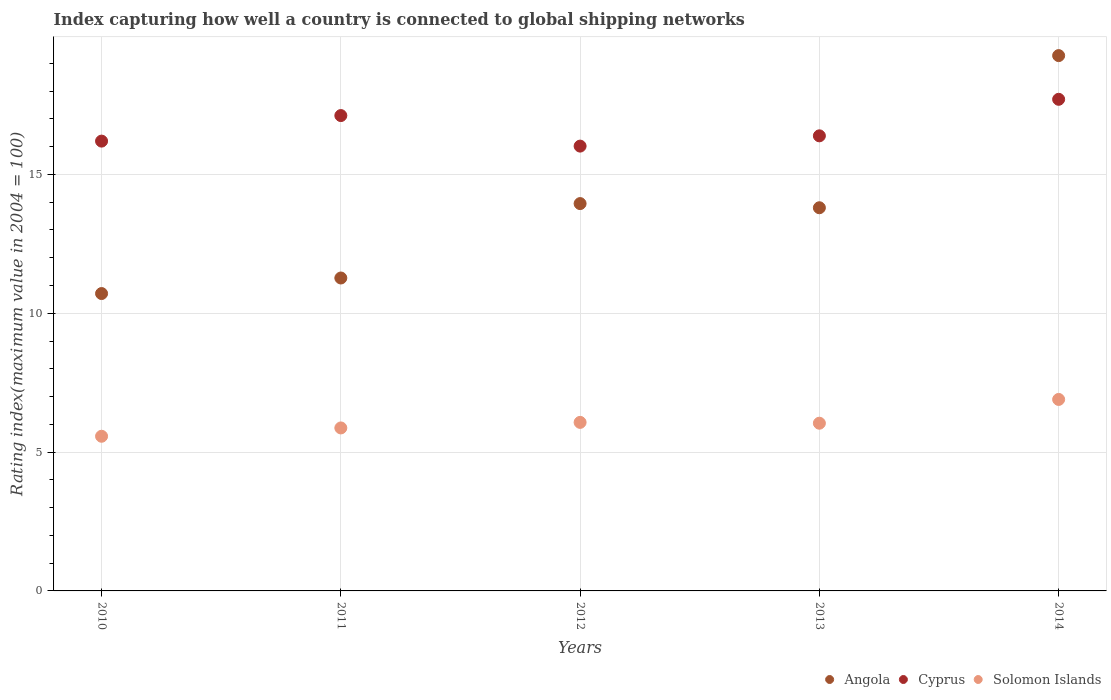How many different coloured dotlines are there?
Your answer should be very brief. 3. What is the rating index in Cyprus in 2010?
Offer a very short reply. 16.2. Across all years, what is the maximum rating index in Angola?
Offer a very short reply. 19.28. Across all years, what is the minimum rating index in Solomon Islands?
Your answer should be very brief. 5.57. What is the total rating index in Cyprus in the graph?
Ensure brevity in your answer.  83.44. What is the difference between the rating index in Cyprus in 2013 and that in 2014?
Keep it short and to the point. -1.32. What is the difference between the rating index in Cyprus in 2011 and the rating index in Angola in 2010?
Your answer should be very brief. 6.41. What is the average rating index in Angola per year?
Offer a terse response. 13.8. In the year 2010, what is the difference between the rating index in Angola and rating index in Cyprus?
Ensure brevity in your answer.  -5.49. What is the ratio of the rating index in Cyprus in 2011 to that in 2014?
Make the answer very short. 0.97. Is the difference between the rating index in Angola in 2011 and 2012 greater than the difference between the rating index in Cyprus in 2011 and 2012?
Ensure brevity in your answer.  No. What is the difference between the highest and the second highest rating index in Cyprus?
Your answer should be very brief. 0.59. What is the difference between the highest and the lowest rating index in Solomon Islands?
Keep it short and to the point. 1.33. Is it the case that in every year, the sum of the rating index in Solomon Islands and rating index in Angola  is greater than the rating index in Cyprus?
Your answer should be compact. Yes. Does the rating index in Angola monotonically increase over the years?
Give a very brief answer. No. Is the rating index in Cyprus strictly greater than the rating index in Solomon Islands over the years?
Ensure brevity in your answer.  Yes. Is the rating index in Solomon Islands strictly less than the rating index in Angola over the years?
Offer a very short reply. Yes. Does the graph contain grids?
Make the answer very short. Yes. Where does the legend appear in the graph?
Your response must be concise. Bottom right. How many legend labels are there?
Provide a short and direct response. 3. How are the legend labels stacked?
Keep it short and to the point. Horizontal. What is the title of the graph?
Ensure brevity in your answer.  Index capturing how well a country is connected to global shipping networks. What is the label or title of the X-axis?
Provide a short and direct response. Years. What is the label or title of the Y-axis?
Your answer should be compact. Rating index(maximum value in 2004 = 100). What is the Rating index(maximum value in 2004 = 100) in Angola in 2010?
Provide a succinct answer. 10.71. What is the Rating index(maximum value in 2004 = 100) in Cyprus in 2010?
Offer a terse response. 16.2. What is the Rating index(maximum value in 2004 = 100) of Solomon Islands in 2010?
Provide a succinct answer. 5.57. What is the Rating index(maximum value in 2004 = 100) in Angola in 2011?
Ensure brevity in your answer.  11.27. What is the Rating index(maximum value in 2004 = 100) of Cyprus in 2011?
Provide a short and direct response. 17.12. What is the Rating index(maximum value in 2004 = 100) of Solomon Islands in 2011?
Your answer should be very brief. 5.87. What is the Rating index(maximum value in 2004 = 100) of Angola in 2012?
Keep it short and to the point. 13.95. What is the Rating index(maximum value in 2004 = 100) of Cyprus in 2012?
Your answer should be very brief. 16.02. What is the Rating index(maximum value in 2004 = 100) in Solomon Islands in 2012?
Keep it short and to the point. 6.07. What is the Rating index(maximum value in 2004 = 100) in Cyprus in 2013?
Your response must be concise. 16.39. What is the Rating index(maximum value in 2004 = 100) of Solomon Islands in 2013?
Make the answer very short. 6.04. What is the Rating index(maximum value in 2004 = 100) of Angola in 2014?
Keep it short and to the point. 19.28. What is the Rating index(maximum value in 2004 = 100) in Cyprus in 2014?
Keep it short and to the point. 17.71. What is the Rating index(maximum value in 2004 = 100) in Solomon Islands in 2014?
Offer a very short reply. 6.9. Across all years, what is the maximum Rating index(maximum value in 2004 = 100) of Angola?
Ensure brevity in your answer.  19.28. Across all years, what is the maximum Rating index(maximum value in 2004 = 100) in Cyprus?
Provide a succinct answer. 17.71. Across all years, what is the maximum Rating index(maximum value in 2004 = 100) in Solomon Islands?
Provide a succinct answer. 6.9. Across all years, what is the minimum Rating index(maximum value in 2004 = 100) in Angola?
Offer a terse response. 10.71. Across all years, what is the minimum Rating index(maximum value in 2004 = 100) in Cyprus?
Ensure brevity in your answer.  16.02. Across all years, what is the minimum Rating index(maximum value in 2004 = 100) of Solomon Islands?
Your answer should be very brief. 5.57. What is the total Rating index(maximum value in 2004 = 100) in Angola in the graph?
Offer a very short reply. 69.01. What is the total Rating index(maximum value in 2004 = 100) in Cyprus in the graph?
Make the answer very short. 83.44. What is the total Rating index(maximum value in 2004 = 100) of Solomon Islands in the graph?
Your answer should be compact. 30.45. What is the difference between the Rating index(maximum value in 2004 = 100) in Angola in 2010 and that in 2011?
Your answer should be very brief. -0.56. What is the difference between the Rating index(maximum value in 2004 = 100) of Cyprus in 2010 and that in 2011?
Offer a terse response. -0.92. What is the difference between the Rating index(maximum value in 2004 = 100) in Solomon Islands in 2010 and that in 2011?
Offer a very short reply. -0.3. What is the difference between the Rating index(maximum value in 2004 = 100) in Angola in 2010 and that in 2012?
Offer a very short reply. -3.24. What is the difference between the Rating index(maximum value in 2004 = 100) of Cyprus in 2010 and that in 2012?
Offer a very short reply. 0.18. What is the difference between the Rating index(maximum value in 2004 = 100) in Angola in 2010 and that in 2013?
Ensure brevity in your answer.  -3.09. What is the difference between the Rating index(maximum value in 2004 = 100) in Cyprus in 2010 and that in 2013?
Your answer should be very brief. -0.19. What is the difference between the Rating index(maximum value in 2004 = 100) in Solomon Islands in 2010 and that in 2013?
Provide a short and direct response. -0.47. What is the difference between the Rating index(maximum value in 2004 = 100) of Angola in 2010 and that in 2014?
Your answer should be very brief. -8.57. What is the difference between the Rating index(maximum value in 2004 = 100) in Cyprus in 2010 and that in 2014?
Offer a very short reply. -1.51. What is the difference between the Rating index(maximum value in 2004 = 100) of Solomon Islands in 2010 and that in 2014?
Provide a succinct answer. -1.33. What is the difference between the Rating index(maximum value in 2004 = 100) in Angola in 2011 and that in 2012?
Ensure brevity in your answer.  -2.68. What is the difference between the Rating index(maximum value in 2004 = 100) of Cyprus in 2011 and that in 2012?
Provide a short and direct response. 1.1. What is the difference between the Rating index(maximum value in 2004 = 100) in Solomon Islands in 2011 and that in 2012?
Offer a very short reply. -0.2. What is the difference between the Rating index(maximum value in 2004 = 100) in Angola in 2011 and that in 2013?
Offer a very short reply. -2.53. What is the difference between the Rating index(maximum value in 2004 = 100) of Cyprus in 2011 and that in 2013?
Your response must be concise. 0.73. What is the difference between the Rating index(maximum value in 2004 = 100) in Solomon Islands in 2011 and that in 2013?
Your response must be concise. -0.17. What is the difference between the Rating index(maximum value in 2004 = 100) of Angola in 2011 and that in 2014?
Your answer should be very brief. -8.01. What is the difference between the Rating index(maximum value in 2004 = 100) in Cyprus in 2011 and that in 2014?
Keep it short and to the point. -0.59. What is the difference between the Rating index(maximum value in 2004 = 100) in Solomon Islands in 2011 and that in 2014?
Provide a short and direct response. -1.03. What is the difference between the Rating index(maximum value in 2004 = 100) of Angola in 2012 and that in 2013?
Offer a terse response. 0.15. What is the difference between the Rating index(maximum value in 2004 = 100) of Cyprus in 2012 and that in 2013?
Offer a terse response. -0.37. What is the difference between the Rating index(maximum value in 2004 = 100) of Angola in 2012 and that in 2014?
Offer a very short reply. -5.33. What is the difference between the Rating index(maximum value in 2004 = 100) in Cyprus in 2012 and that in 2014?
Make the answer very short. -1.69. What is the difference between the Rating index(maximum value in 2004 = 100) of Solomon Islands in 2012 and that in 2014?
Keep it short and to the point. -0.83. What is the difference between the Rating index(maximum value in 2004 = 100) in Angola in 2013 and that in 2014?
Offer a very short reply. -5.48. What is the difference between the Rating index(maximum value in 2004 = 100) of Cyprus in 2013 and that in 2014?
Offer a very short reply. -1.32. What is the difference between the Rating index(maximum value in 2004 = 100) of Solomon Islands in 2013 and that in 2014?
Give a very brief answer. -0.86. What is the difference between the Rating index(maximum value in 2004 = 100) in Angola in 2010 and the Rating index(maximum value in 2004 = 100) in Cyprus in 2011?
Your response must be concise. -6.41. What is the difference between the Rating index(maximum value in 2004 = 100) in Angola in 2010 and the Rating index(maximum value in 2004 = 100) in Solomon Islands in 2011?
Give a very brief answer. 4.84. What is the difference between the Rating index(maximum value in 2004 = 100) in Cyprus in 2010 and the Rating index(maximum value in 2004 = 100) in Solomon Islands in 2011?
Your answer should be compact. 10.33. What is the difference between the Rating index(maximum value in 2004 = 100) of Angola in 2010 and the Rating index(maximum value in 2004 = 100) of Cyprus in 2012?
Give a very brief answer. -5.31. What is the difference between the Rating index(maximum value in 2004 = 100) in Angola in 2010 and the Rating index(maximum value in 2004 = 100) in Solomon Islands in 2012?
Give a very brief answer. 4.64. What is the difference between the Rating index(maximum value in 2004 = 100) in Cyprus in 2010 and the Rating index(maximum value in 2004 = 100) in Solomon Islands in 2012?
Ensure brevity in your answer.  10.13. What is the difference between the Rating index(maximum value in 2004 = 100) in Angola in 2010 and the Rating index(maximum value in 2004 = 100) in Cyprus in 2013?
Your answer should be compact. -5.68. What is the difference between the Rating index(maximum value in 2004 = 100) of Angola in 2010 and the Rating index(maximum value in 2004 = 100) of Solomon Islands in 2013?
Your answer should be compact. 4.67. What is the difference between the Rating index(maximum value in 2004 = 100) of Cyprus in 2010 and the Rating index(maximum value in 2004 = 100) of Solomon Islands in 2013?
Ensure brevity in your answer.  10.16. What is the difference between the Rating index(maximum value in 2004 = 100) in Angola in 2010 and the Rating index(maximum value in 2004 = 100) in Cyprus in 2014?
Give a very brief answer. -7. What is the difference between the Rating index(maximum value in 2004 = 100) in Angola in 2010 and the Rating index(maximum value in 2004 = 100) in Solomon Islands in 2014?
Give a very brief answer. 3.81. What is the difference between the Rating index(maximum value in 2004 = 100) of Cyprus in 2010 and the Rating index(maximum value in 2004 = 100) of Solomon Islands in 2014?
Provide a succinct answer. 9.3. What is the difference between the Rating index(maximum value in 2004 = 100) of Angola in 2011 and the Rating index(maximum value in 2004 = 100) of Cyprus in 2012?
Provide a succinct answer. -4.75. What is the difference between the Rating index(maximum value in 2004 = 100) of Angola in 2011 and the Rating index(maximum value in 2004 = 100) of Solomon Islands in 2012?
Your answer should be very brief. 5.2. What is the difference between the Rating index(maximum value in 2004 = 100) of Cyprus in 2011 and the Rating index(maximum value in 2004 = 100) of Solomon Islands in 2012?
Your answer should be compact. 11.05. What is the difference between the Rating index(maximum value in 2004 = 100) of Angola in 2011 and the Rating index(maximum value in 2004 = 100) of Cyprus in 2013?
Make the answer very short. -5.12. What is the difference between the Rating index(maximum value in 2004 = 100) in Angola in 2011 and the Rating index(maximum value in 2004 = 100) in Solomon Islands in 2013?
Give a very brief answer. 5.23. What is the difference between the Rating index(maximum value in 2004 = 100) in Cyprus in 2011 and the Rating index(maximum value in 2004 = 100) in Solomon Islands in 2013?
Your answer should be compact. 11.08. What is the difference between the Rating index(maximum value in 2004 = 100) in Angola in 2011 and the Rating index(maximum value in 2004 = 100) in Cyprus in 2014?
Offer a terse response. -6.44. What is the difference between the Rating index(maximum value in 2004 = 100) in Angola in 2011 and the Rating index(maximum value in 2004 = 100) in Solomon Islands in 2014?
Offer a very short reply. 4.37. What is the difference between the Rating index(maximum value in 2004 = 100) of Cyprus in 2011 and the Rating index(maximum value in 2004 = 100) of Solomon Islands in 2014?
Make the answer very short. 10.22. What is the difference between the Rating index(maximum value in 2004 = 100) in Angola in 2012 and the Rating index(maximum value in 2004 = 100) in Cyprus in 2013?
Your response must be concise. -2.44. What is the difference between the Rating index(maximum value in 2004 = 100) of Angola in 2012 and the Rating index(maximum value in 2004 = 100) of Solomon Islands in 2013?
Your answer should be very brief. 7.91. What is the difference between the Rating index(maximum value in 2004 = 100) in Cyprus in 2012 and the Rating index(maximum value in 2004 = 100) in Solomon Islands in 2013?
Provide a succinct answer. 9.98. What is the difference between the Rating index(maximum value in 2004 = 100) of Angola in 2012 and the Rating index(maximum value in 2004 = 100) of Cyprus in 2014?
Offer a very short reply. -3.76. What is the difference between the Rating index(maximum value in 2004 = 100) in Angola in 2012 and the Rating index(maximum value in 2004 = 100) in Solomon Islands in 2014?
Provide a succinct answer. 7.05. What is the difference between the Rating index(maximum value in 2004 = 100) in Cyprus in 2012 and the Rating index(maximum value in 2004 = 100) in Solomon Islands in 2014?
Make the answer very short. 9.12. What is the difference between the Rating index(maximum value in 2004 = 100) in Angola in 2013 and the Rating index(maximum value in 2004 = 100) in Cyprus in 2014?
Provide a short and direct response. -3.91. What is the difference between the Rating index(maximum value in 2004 = 100) of Angola in 2013 and the Rating index(maximum value in 2004 = 100) of Solomon Islands in 2014?
Keep it short and to the point. 6.9. What is the difference between the Rating index(maximum value in 2004 = 100) of Cyprus in 2013 and the Rating index(maximum value in 2004 = 100) of Solomon Islands in 2014?
Your answer should be very brief. 9.49. What is the average Rating index(maximum value in 2004 = 100) of Angola per year?
Your answer should be very brief. 13.8. What is the average Rating index(maximum value in 2004 = 100) in Cyprus per year?
Keep it short and to the point. 16.69. What is the average Rating index(maximum value in 2004 = 100) of Solomon Islands per year?
Provide a short and direct response. 6.09. In the year 2010, what is the difference between the Rating index(maximum value in 2004 = 100) in Angola and Rating index(maximum value in 2004 = 100) in Cyprus?
Your response must be concise. -5.49. In the year 2010, what is the difference between the Rating index(maximum value in 2004 = 100) in Angola and Rating index(maximum value in 2004 = 100) in Solomon Islands?
Offer a terse response. 5.14. In the year 2010, what is the difference between the Rating index(maximum value in 2004 = 100) of Cyprus and Rating index(maximum value in 2004 = 100) of Solomon Islands?
Give a very brief answer. 10.63. In the year 2011, what is the difference between the Rating index(maximum value in 2004 = 100) in Angola and Rating index(maximum value in 2004 = 100) in Cyprus?
Provide a succinct answer. -5.85. In the year 2011, what is the difference between the Rating index(maximum value in 2004 = 100) in Cyprus and Rating index(maximum value in 2004 = 100) in Solomon Islands?
Make the answer very short. 11.25. In the year 2012, what is the difference between the Rating index(maximum value in 2004 = 100) of Angola and Rating index(maximum value in 2004 = 100) of Cyprus?
Provide a short and direct response. -2.07. In the year 2012, what is the difference between the Rating index(maximum value in 2004 = 100) in Angola and Rating index(maximum value in 2004 = 100) in Solomon Islands?
Make the answer very short. 7.88. In the year 2012, what is the difference between the Rating index(maximum value in 2004 = 100) of Cyprus and Rating index(maximum value in 2004 = 100) of Solomon Islands?
Provide a succinct answer. 9.95. In the year 2013, what is the difference between the Rating index(maximum value in 2004 = 100) in Angola and Rating index(maximum value in 2004 = 100) in Cyprus?
Your response must be concise. -2.59. In the year 2013, what is the difference between the Rating index(maximum value in 2004 = 100) in Angola and Rating index(maximum value in 2004 = 100) in Solomon Islands?
Give a very brief answer. 7.76. In the year 2013, what is the difference between the Rating index(maximum value in 2004 = 100) of Cyprus and Rating index(maximum value in 2004 = 100) of Solomon Islands?
Provide a short and direct response. 10.35. In the year 2014, what is the difference between the Rating index(maximum value in 2004 = 100) in Angola and Rating index(maximum value in 2004 = 100) in Cyprus?
Ensure brevity in your answer.  1.57. In the year 2014, what is the difference between the Rating index(maximum value in 2004 = 100) of Angola and Rating index(maximum value in 2004 = 100) of Solomon Islands?
Give a very brief answer. 12.38. In the year 2014, what is the difference between the Rating index(maximum value in 2004 = 100) in Cyprus and Rating index(maximum value in 2004 = 100) in Solomon Islands?
Give a very brief answer. 10.81. What is the ratio of the Rating index(maximum value in 2004 = 100) of Angola in 2010 to that in 2011?
Your response must be concise. 0.95. What is the ratio of the Rating index(maximum value in 2004 = 100) of Cyprus in 2010 to that in 2011?
Your answer should be compact. 0.95. What is the ratio of the Rating index(maximum value in 2004 = 100) in Solomon Islands in 2010 to that in 2011?
Give a very brief answer. 0.95. What is the ratio of the Rating index(maximum value in 2004 = 100) of Angola in 2010 to that in 2012?
Make the answer very short. 0.77. What is the ratio of the Rating index(maximum value in 2004 = 100) in Cyprus in 2010 to that in 2012?
Your answer should be very brief. 1.01. What is the ratio of the Rating index(maximum value in 2004 = 100) in Solomon Islands in 2010 to that in 2012?
Ensure brevity in your answer.  0.92. What is the ratio of the Rating index(maximum value in 2004 = 100) in Angola in 2010 to that in 2013?
Provide a succinct answer. 0.78. What is the ratio of the Rating index(maximum value in 2004 = 100) in Cyprus in 2010 to that in 2013?
Keep it short and to the point. 0.99. What is the ratio of the Rating index(maximum value in 2004 = 100) in Solomon Islands in 2010 to that in 2013?
Make the answer very short. 0.92. What is the ratio of the Rating index(maximum value in 2004 = 100) in Angola in 2010 to that in 2014?
Your response must be concise. 0.56. What is the ratio of the Rating index(maximum value in 2004 = 100) in Cyprus in 2010 to that in 2014?
Your response must be concise. 0.92. What is the ratio of the Rating index(maximum value in 2004 = 100) of Solomon Islands in 2010 to that in 2014?
Provide a succinct answer. 0.81. What is the ratio of the Rating index(maximum value in 2004 = 100) of Angola in 2011 to that in 2012?
Offer a terse response. 0.81. What is the ratio of the Rating index(maximum value in 2004 = 100) in Cyprus in 2011 to that in 2012?
Your response must be concise. 1.07. What is the ratio of the Rating index(maximum value in 2004 = 100) in Solomon Islands in 2011 to that in 2012?
Your answer should be very brief. 0.97. What is the ratio of the Rating index(maximum value in 2004 = 100) of Angola in 2011 to that in 2013?
Provide a short and direct response. 0.82. What is the ratio of the Rating index(maximum value in 2004 = 100) of Cyprus in 2011 to that in 2013?
Provide a short and direct response. 1.04. What is the ratio of the Rating index(maximum value in 2004 = 100) of Solomon Islands in 2011 to that in 2013?
Offer a very short reply. 0.97. What is the ratio of the Rating index(maximum value in 2004 = 100) of Angola in 2011 to that in 2014?
Give a very brief answer. 0.58. What is the ratio of the Rating index(maximum value in 2004 = 100) of Cyprus in 2011 to that in 2014?
Ensure brevity in your answer.  0.97. What is the ratio of the Rating index(maximum value in 2004 = 100) of Solomon Islands in 2011 to that in 2014?
Ensure brevity in your answer.  0.85. What is the ratio of the Rating index(maximum value in 2004 = 100) of Angola in 2012 to that in 2013?
Provide a short and direct response. 1.01. What is the ratio of the Rating index(maximum value in 2004 = 100) in Cyprus in 2012 to that in 2013?
Offer a very short reply. 0.98. What is the ratio of the Rating index(maximum value in 2004 = 100) in Solomon Islands in 2012 to that in 2013?
Ensure brevity in your answer.  1. What is the ratio of the Rating index(maximum value in 2004 = 100) of Angola in 2012 to that in 2014?
Provide a succinct answer. 0.72. What is the ratio of the Rating index(maximum value in 2004 = 100) of Cyprus in 2012 to that in 2014?
Your response must be concise. 0.9. What is the ratio of the Rating index(maximum value in 2004 = 100) of Solomon Islands in 2012 to that in 2014?
Provide a succinct answer. 0.88. What is the ratio of the Rating index(maximum value in 2004 = 100) of Angola in 2013 to that in 2014?
Provide a short and direct response. 0.72. What is the ratio of the Rating index(maximum value in 2004 = 100) of Cyprus in 2013 to that in 2014?
Your response must be concise. 0.93. What is the ratio of the Rating index(maximum value in 2004 = 100) in Solomon Islands in 2013 to that in 2014?
Give a very brief answer. 0.88. What is the difference between the highest and the second highest Rating index(maximum value in 2004 = 100) in Angola?
Your answer should be compact. 5.33. What is the difference between the highest and the second highest Rating index(maximum value in 2004 = 100) in Cyprus?
Provide a short and direct response. 0.59. What is the difference between the highest and the second highest Rating index(maximum value in 2004 = 100) of Solomon Islands?
Your answer should be compact. 0.83. What is the difference between the highest and the lowest Rating index(maximum value in 2004 = 100) of Angola?
Provide a succinct answer. 8.57. What is the difference between the highest and the lowest Rating index(maximum value in 2004 = 100) in Cyprus?
Provide a succinct answer. 1.69. What is the difference between the highest and the lowest Rating index(maximum value in 2004 = 100) in Solomon Islands?
Your response must be concise. 1.33. 